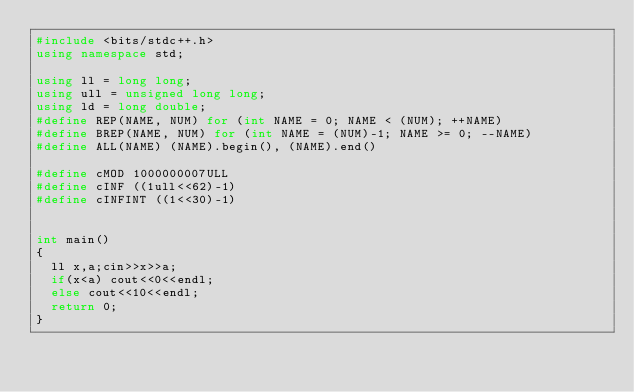Convert code to text. <code><loc_0><loc_0><loc_500><loc_500><_C++_>#include <bits/stdc++.h>
using namespace std;

using ll = long long;
using ull = unsigned long long;
using ld = long double;
#define REP(NAME, NUM) for (int NAME = 0; NAME < (NUM); ++NAME)
#define BREP(NAME, NUM) for (int NAME = (NUM)-1; NAME >= 0; --NAME)
#define ALL(NAME) (NAME).begin(), (NAME).end()

#define cMOD 1000000007ULL
#define cINF ((1ull<<62)-1)
#define cINFINT ((1<<30)-1)


int main()
{
	ll x,a;cin>>x>>a;
	if(x<a) cout<<0<<endl;
	else cout<<10<<endl;
	return 0;
}</code> 